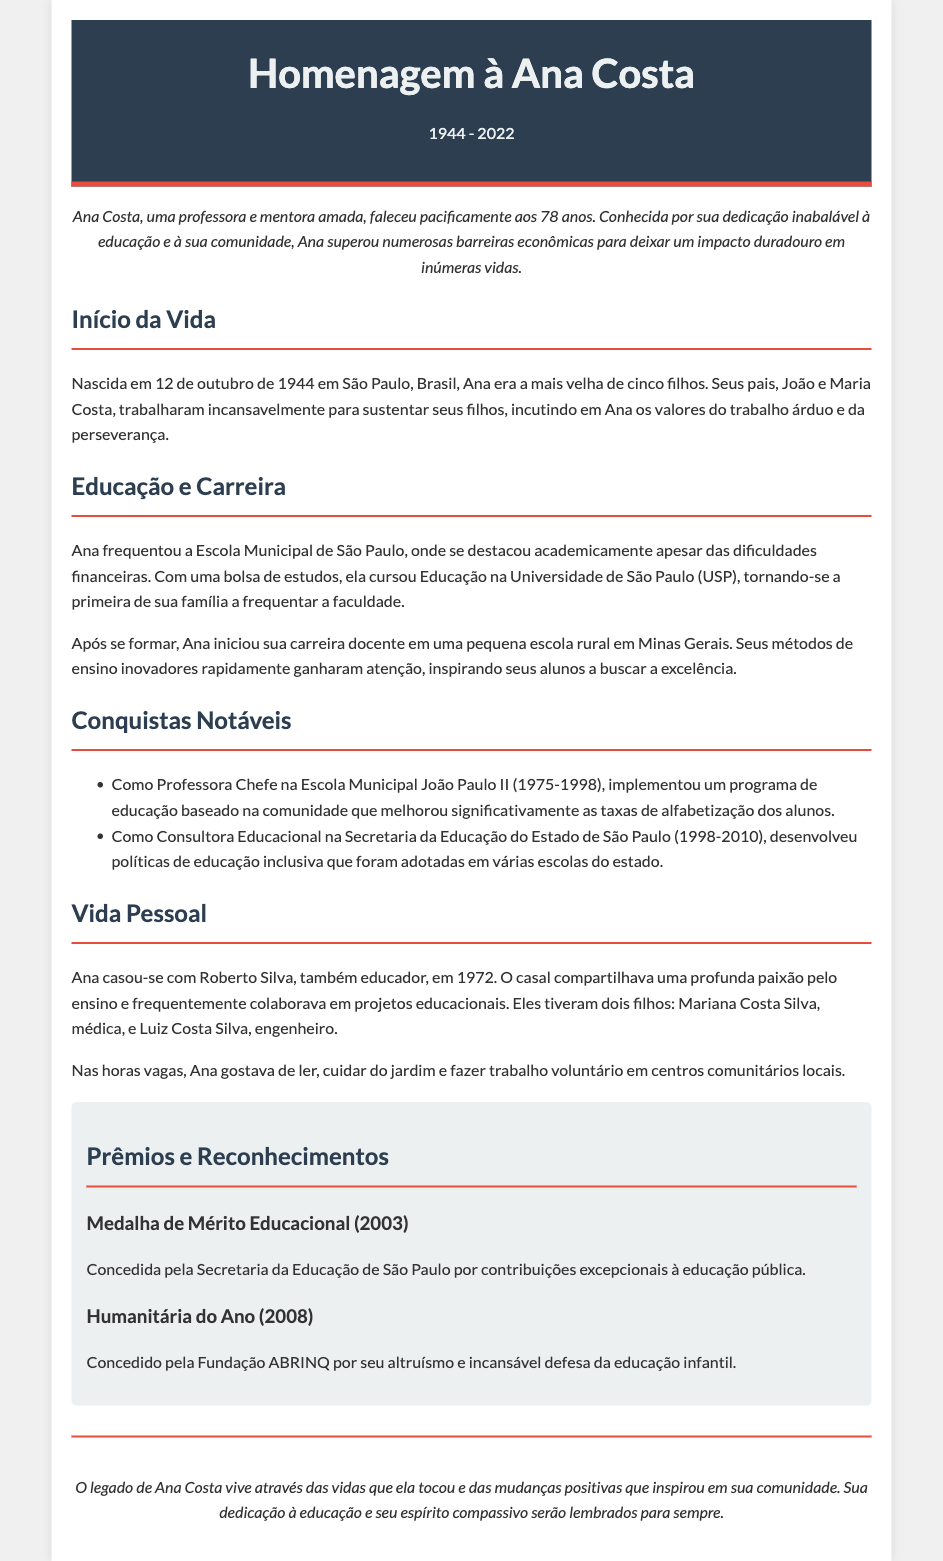what year was Ana Costa born? Ana Costa was born on October 12, 1944.
Answer: 1944 what was Ana Costa's profession? Ana Costa was a teacher and mentor.
Answer: professora how many children did Ana Costa have? Ana Costa had two children, Mariana and Luiz.
Answer: dois which award did Ana receive in 2003? Ana received the Medalha de Mérito Educacional in 2003.
Answer: Medalha de Mérito Educacional what community-related program did Ana implement? Ana implemented a community-based education program that improved literacy rates.
Answer: programa de educação baseado na comunidade how long did Ana work at the Escola Municipal João Paulo II? Ana worked there from 1975 to 1998.
Answer: 23 anos who was Ana Costa's husband? Ana Costa's husband was Roberto Silva.
Answer: Roberto Silva what was a key aspect of Ana's personal life? Ana enjoyed reading and volunteering in her community.
Answer: cuidar do jardim 